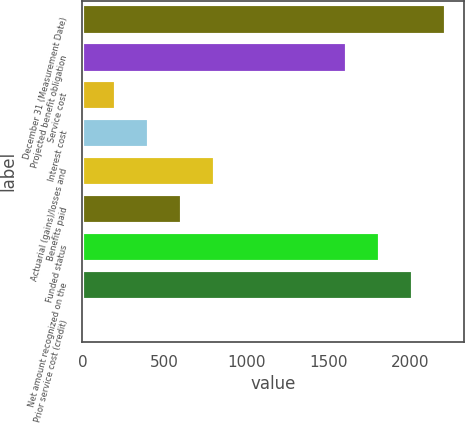<chart> <loc_0><loc_0><loc_500><loc_500><bar_chart><fcel>December 31 (Measurement Date)<fcel>Projected benefit obligation<fcel>Service cost<fcel>Interest cost<fcel>Actuarial (gains)/losses and<fcel>Benefits paid<fcel>Funded status<fcel>Net amount recognized on the<fcel>Prior service cost (credit)<nl><fcel>2215.3<fcel>1611.4<fcel>202.3<fcel>403.6<fcel>806.2<fcel>604.9<fcel>1812.7<fcel>2014<fcel>1<nl></chart> 